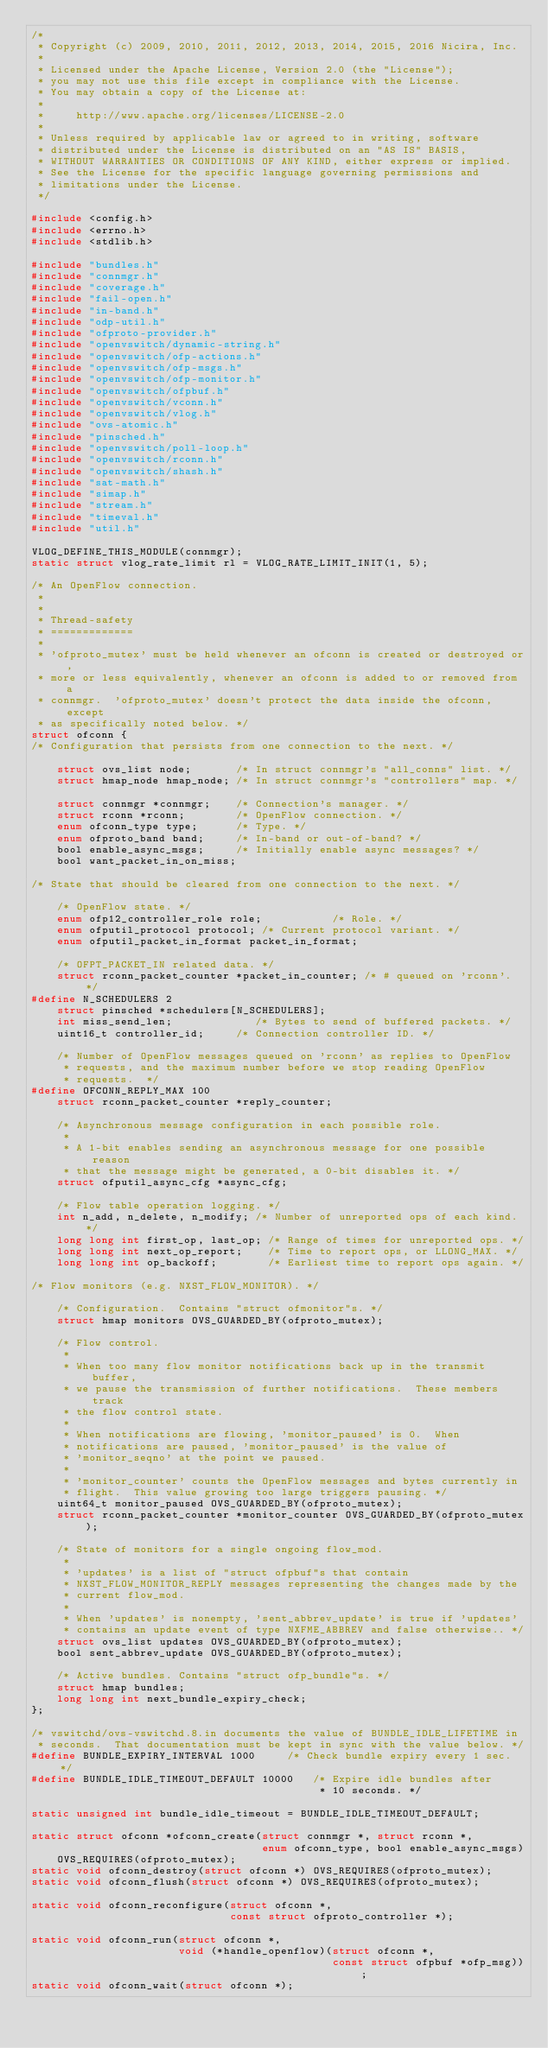<code> <loc_0><loc_0><loc_500><loc_500><_C_>/*
 * Copyright (c) 2009, 2010, 2011, 2012, 2013, 2014, 2015, 2016 Nicira, Inc.
 *
 * Licensed under the Apache License, Version 2.0 (the "License");
 * you may not use this file except in compliance with the License.
 * You may obtain a copy of the License at:
 *
 *     http://www.apache.org/licenses/LICENSE-2.0
 *
 * Unless required by applicable law or agreed to in writing, software
 * distributed under the License is distributed on an "AS IS" BASIS,
 * WITHOUT WARRANTIES OR CONDITIONS OF ANY KIND, either express or implied.
 * See the License for the specific language governing permissions and
 * limitations under the License.
 */

#include <config.h>
#include <errno.h>
#include <stdlib.h>

#include "bundles.h"
#include "connmgr.h"
#include "coverage.h"
#include "fail-open.h"
#include "in-band.h"
#include "odp-util.h"
#include "ofproto-provider.h"
#include "openvswitch/dynamic-string.h"
#include "openvswitch/ofp-actions.h"
#include "openvswitch/ofp-msgs.h"
#include "openvswitch/ofp-monitor.h"
#include "openvswitch/ofpbuf.h"
#include "openvswitch/vconn.h"
#include "openvswitch/vlog.h"
#include "ovs-atomic.h"
#include "pinsched.h"
#include "openvswitch/poll-loop.h"
#include "openvswitch/rconn.h"
#include "openvswitch/shash.h"
#include "sat-math.h"
#include "simap.h"
#include "stream.h"
#include "timeval.h"
#include "util.h"

VLOG_DEFINE_THIS_MODULE(connmgr);
static struct vlog_rate_limit rl = VLOG_RATE_LIMIT_INIT(1, 5);

/* An OpenFlow connection.
 *
 *
 * Thread-safety
 * =============
 *
 * 'ofproto_mutex' must be held whenever an ofconn is created or destroyed or,
 * more or less equivalently, whenever an ofconn is added to or removed from a
 * connmgr.  'ofproto_mutex' doesn't protect the data inside the ofconn, except
 * as specifically noted below. */
struct ofconn {
/* Configuration that persists from one connection to the next. */

    struct ovs_list node;       /* In struct connmgr's "all_conns" list. */
    struct hmap_node hmap_node; /* In struct connmgr's "controllers" map. */

    struct connmgr *connmgr;    /* Connection's manager. */
    struct rconn *rconn;        /* OpenFlow connection. */
    enum ofconn_type type;      /* Type. */
    enum ofproto_band band;     /* In-band or out-of-band? */
    bool enable_async_msgs;     /* Initially enable async messages? */
    bool want_packet_in_on_miss;

/* State that should be cleared from one connection to the next. */

    /* OpenFlow state. */
    enum ofp12_controller_role role;           /* Role. */
    enum ofputil_protocol protocol; /* Current protocol variant. */
    enum ofputil_packet_in_format packet_in_format;

    /* OFPT_PACKET_IN related data. */
    struct rconn_packet_counter *packet_in_counter; /* # queued on 'rconn'. */
#define N_SCHEDULERS 2
    struct pinsched *schedulers[N_SCHEDULERS];
    int miss_send_len;             /* Bytes to send of buffered packets. */
    uint16_t controller_id;     /* Connection controller ID. */

    /* Number of OpenFlow messages queued on 'rconn' as replies to OpenFlow
     * requests, and the maximum number before we stop reading OpenFlow
     * requests.  */
#define OFCONN_REPLY_MAX 100
    struct rconn_packet_counter *reply_counter;

    /* Asynchronous message configuration in each possible role.
     *
     * A 1-bit enables sending an asynchronous message for one possible reason
     * that the message might be generated, a 0-bit disables it. */
    struct ofputil_async_cfg *async_cfg;

    /* Flow table operation logging. */
    int n_add, n_delete, n_modify; /* Number of unreported ops of each kind. */
    long long int first_op, last_op; /* Range of times for unreported ops. */
    long long int next_op_report;    /* Time to report ops, or LLONG_MAX. */
    long long int op_backoff;        /* Earliest time to report ops again. */

/* Flow monitors (e.g. NXST_FLOW_MONITOR). */

    /* Configuration.  Contains "struct ofmonitor"s. */
    struct hmap monitors OVS_GUARDED_BY(ofproto_mutex);

    /* Flow control.
     *
     * When too many flow monitor notifications back up in the transmit buffer,
     * we pause the transmission of further notifications.  These members track
     * the flow control state.
     *
     * When notifications are flowing, 'monitor_paused' is 0.  When
     * notifications are paused, 'monitor_paused' is the value of
     * 'monitor_seqno' at the point we paused.
     *
     * 'monitor_counter' counts the OpenFlow messages and bytes currently in
     * flight.  This value growing too large triggers pausing. */
    uint64_t monitor_paused OVS_GUARDED_BY(ofproto_mutex);
    struct rconn_packet_counter *monitor_counter OVS_GUARDED_BY(ofproto_mutex);

    /* State of monitors for a single ongoing flow_mod.
     *
     * 'updates' is a list of "struct ofpbuf"s that contain
     * NXST_FLOW_MONITOR_REPLY messages representing the changes made by the
     * current flow_mod.
     *
     * When 'updates' is nonempty, 'sent_abbrev_update' is true if 'updates'
     * contains an update event of type NXFME_ABBREV and false otherwise.. */
    struct ovs_list updates OVS_GUARDED_BY(ofproto_mutex);
    bool sent_abbrev_update OVS_GUARDED_BY(ofproto_mutex);

    /* Active bundles. Contains "struct ofp_bundle"s. */
    struct hmap bundles;
    long long int next_bundle_expiry_check;
};

/* vswitchd/ovs-vswitchd.8.in documents the value of BUNDLE_IDLE_LIFETIME in
 * seconds.  That documentation must be kept in sync with the value below. */
#define BUNDLE_EXPIRY_INTERVAL 1000     /* Check bundle expiry every 1 sec. */
#define BUNDLE_IDLE_TIMEOUT_DEFAULT 10000   /* Expire idle bundles after
                                             * 10 seconds. */

static unsigned int bundle_idle_timeout = BUNDLE_IDLE_TIMEOUT_DEFAULT;

static struct ofconn *ofconn_create(struct connmgr *, struct rconn *,
                                    enum ofconn_type, bool enable_async_msgs)
    OVS_REQUIRES(ofproto_mutex);
static void ofconn_destroy(struct ofconn *) OVS_REQUIRES(ofproto_mutex);
static void ofconn_flush(struct ofconn *) OVS_REQUIRES(ofproto_mutex);

static void ofconn_reconfigure(struct ofconn *,
                               const struct ofproto_controller *);

static void ofconn_run(struct ofconn *,
                       void (*handle_openflow)(struct ofconn *,
                                               const struct ofpbuf *ofp_msg));
static void ofconn_wait(struct ofconn *);
</code> 